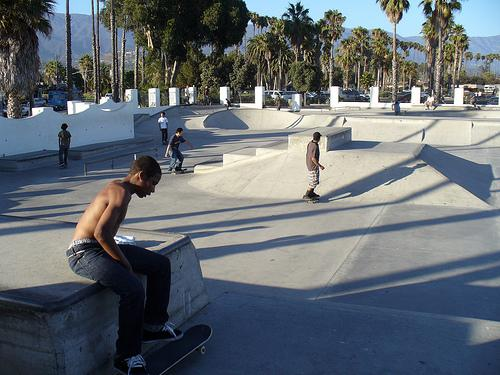Question: how are the people moving?
Choices:
A. Skateboards.
B. By train.
C. By car.
D. On bikes.
Answer with the letter. Answer: A Question: when was this photo taken?
Choices:
A. At Night.
B. In the day.
C. On Fathers Day.
D. On Mothers Day.
Answer with the letter. Answer: B Question: what are the people doing?
Choices:
A. Skating.
B. Eating.
C. Smiling.
D. Yelling.
Answer with the letter. Answer: A Question: why are there ramps?
Choices:
A. For wheel chair access.
B. To park cars.
C. For the skaters to skate on.
D. To direct traffic.
Answer with the letter. Answer: C Question: what is the man in the foreground doing?
Choices:
A. Sitting.
B. Laughing.
C. Doing magic tricks.
D. Smiling.
Answer with the letter. Answer: A 